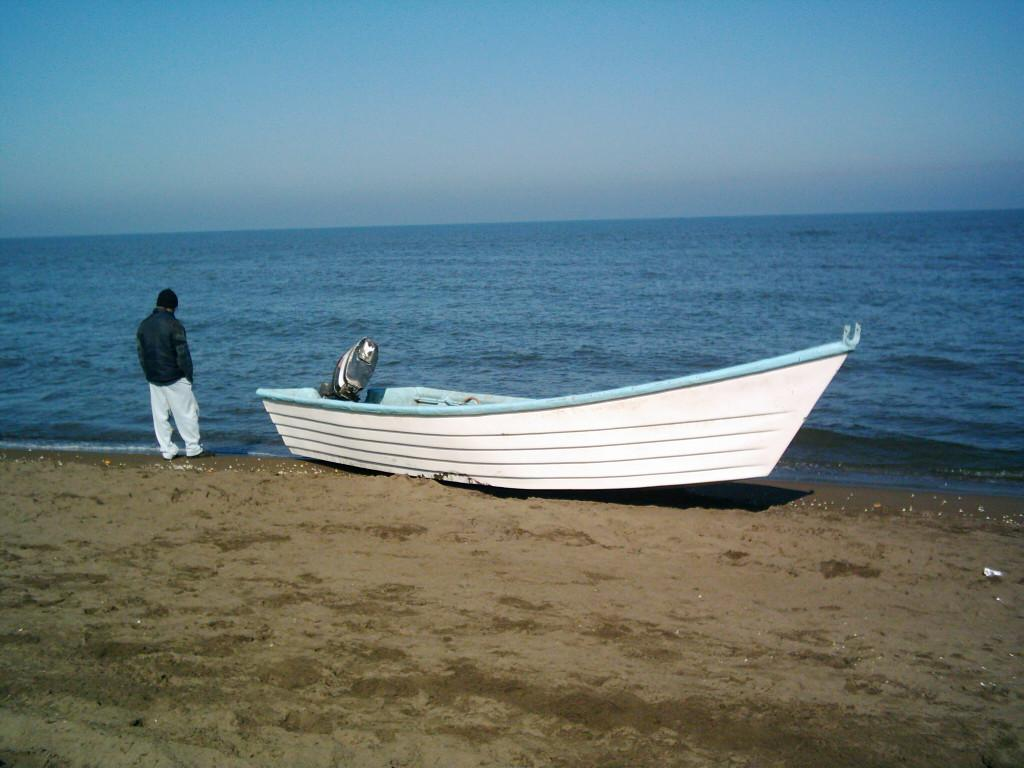What is the person doing in the image? The person is standing on the beach. What else can be seen on the beach besides the person? There is a boat on the beach. What is visible in the background of the image? Water and clouds are present in the image. What type of surface is the person standing on? Sand is present on the beach, which is the surface the person is standing on. How many women are operating the train in the image? There is no train present in the image, so it is not possible to answer that question. 